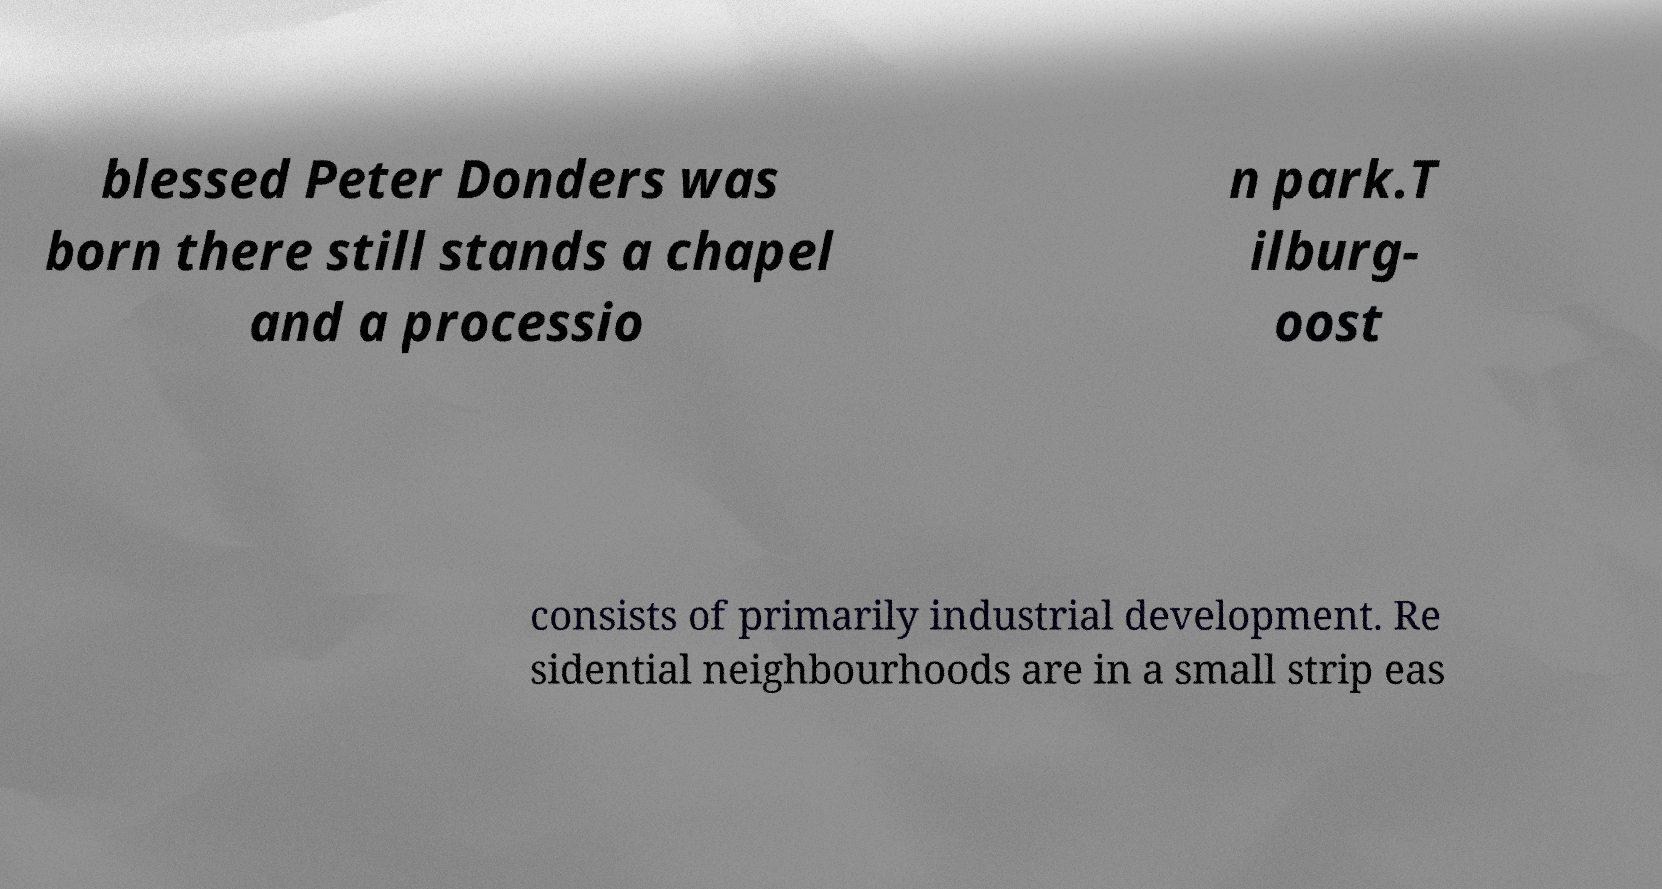Please read and relay the text visible in this image. What does it say? blessed Peter Donders was born there still stands a chapel and a processio n park.T ilburg- oost consists of primarily industrial development. Re sidential neighbourhoods are in a small strip eas 